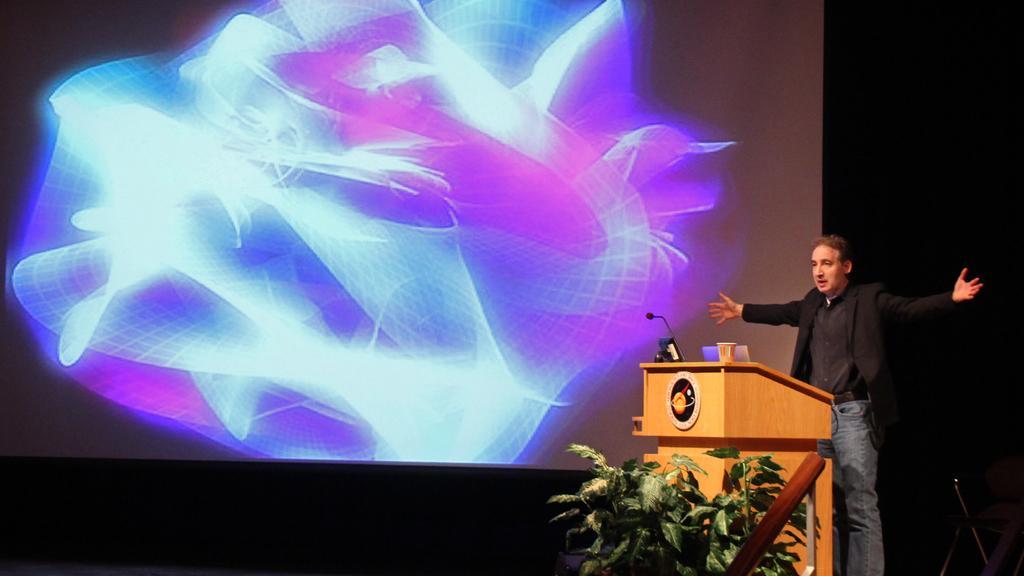Describe this image in one or two sentences. In this image we can see a person standing and there is a podium with a mic and some other things and we can see a few plants in front of the podium. In the background, we can see the screen with some picture. 